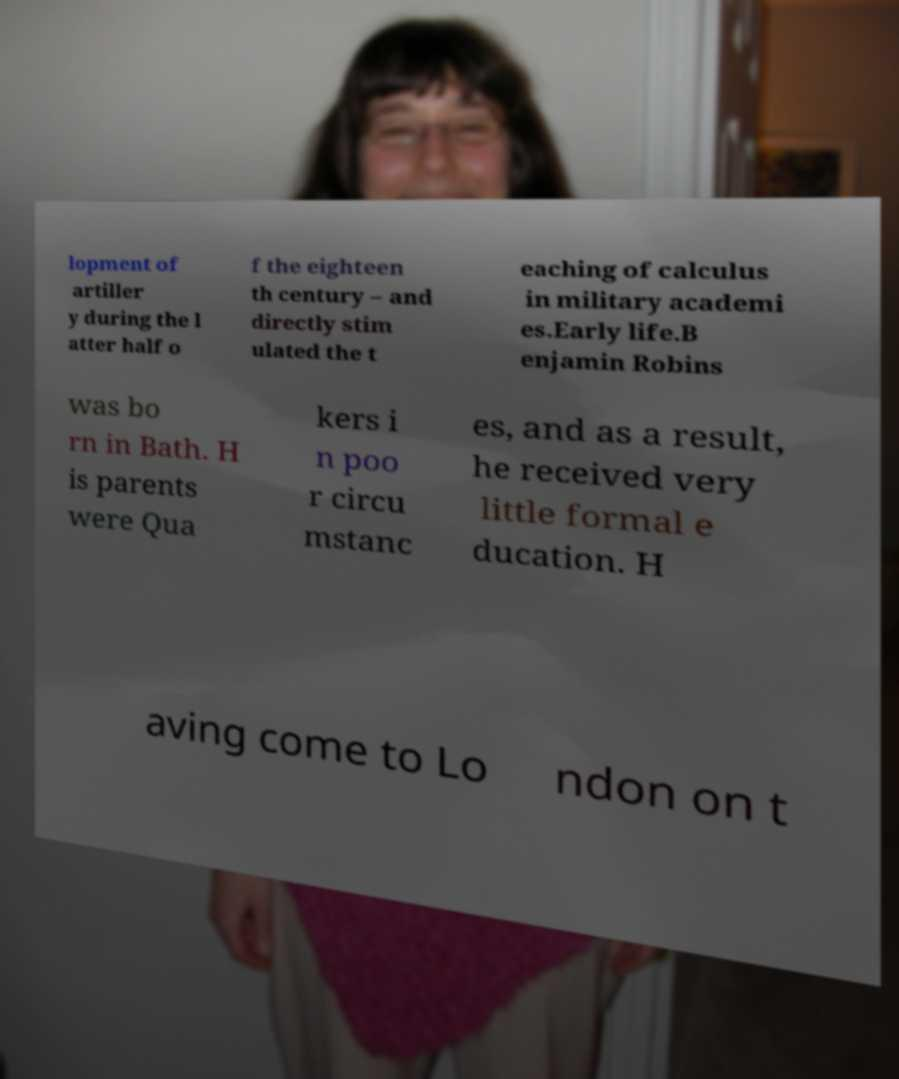I need the written content from this picture converted into text. Can you do that? lopment of artiller y during the l atter half o f the eighteen th century – and directly stim ulated the t eaching of calculus in military academi es.Early life.B enjamin Robins was bo rn in Bath. H is parents were Qua kers i n poo r circu mstanc es, and as a result, he received very little formal e ducation. H aving come to Lo ndon on t 